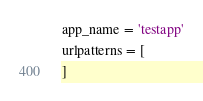<code> <loc_0><loc_0><loc_500><loc_500><_Python_>
app_name = 'testapp'
urlpatterns = [
]
</code> 